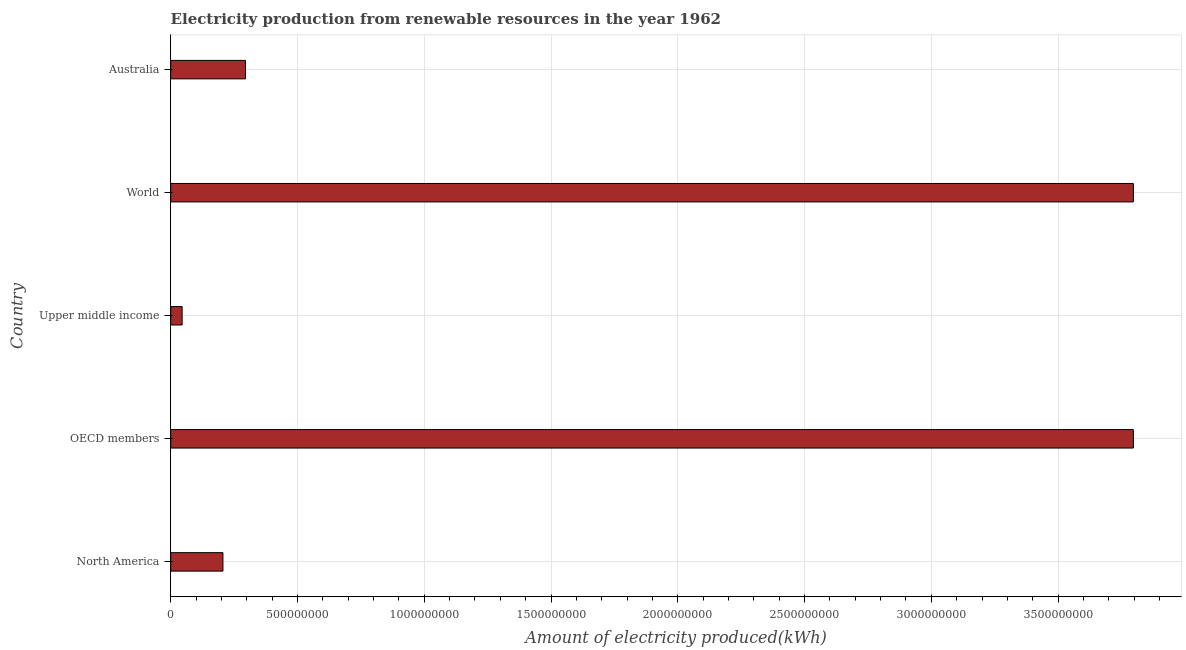Does the graph contain any zero values?
Offer a very short reply. No. Does the graph contain grids?
Provide a short and direct response. Yes. What is the title of the graph?
Ensure brevity in your answer.  Electricity production from renewable resources in the year 1962. What is the label or title of the X-axis?
Your answer should be very brief. Amount of electricity produced(kWh). What is the label or title of the Y-axis?
Offer a terse response. Country. What is the amount of electricity produced in Upper middle income?
Provide a succinct answer. 4.50e+07. Across all countries, what is the maximum amount of electricity produced?
Offer a terse response. 3.80e+09. Across all countries, what is the minimum amount of electricity produced?
Make the answer very short. 4.50e+07. In which country was the amount of electricity produced maximum?
Ensure brevity in your answer.  OECD members. In which country was the amount of electricity produced minimum?
Give a very brief answer. Upper middle income. What is the sum of the amount of electricity produced?
Ensure brevity in your answer.  8.14e+09. What is the difference between the amount of electricity produced in Australia and Upper middle income?
Offer a very short reply. 2.50e+08. What is the average amount of electricity produced per country?
Offer a terse response. 1.63e+09. What is the median amount of electricity produced?
Your response must be concise. 2.95e+08. In how many countries, is the amount of electricity produced greater than 200000000 kWh?
Make the answer very short. 4. What is the ratio of the amount of electricity produced in North America to that in OECD members?
Give a very brief answer. 0.05. What is the difference between the highest and the lowest amount of electricity produced?
Ensure brevity in your answer.  3.75e+09. In how many countries, is the amount of electricity produced greater than the average amount of electricity produced taken over all countries?
Your answer should be very brief. 2. Are all the bars in the graph horizontal?
Keep it short and to the point. Yes. How many countries are there in the graph?
Ensure brevity in your answer.  5. Are the values on the major ticks of X-axis written in scientific E-notation?
Make the answer very short. No. What is the Amount of electricity produced(kWh) of North America?
Offer a terse response. 2.06e+08. What is the Amount of electricity produced(kWh) in OECD members?
Your response must be concise. 3.80e+09. What is the Amount of electricity produced(kWh) of Upper middle income?
Provide a succinct answer. 4.50e+07. What is the Amount of electricity produced(kWh) in World?
Ensure brevity in your answer.  3.80e+09. What is the Amount of electricity produced(kWh) in Australia?
Provide a short and direct response. 2.95e+08. What is the difference between the Amount of electricity produced(kWh) in North America and OECD members?
Offer a terse response. -3.59e+09. What is the difference between the Amount of electricity produced(kWh) in North America and Upper middle income?
Keep it short and to the point. 1.61e+08. What is the difference between the Amount of electricity produced(kWh) in North America and World?
Ensure brevity in your answer.  -3.59e+09. What is the difference between the Amount of electricity produced(kWh) in North America and Australia?
Keep it short and to the point. -8.90e+07. What is the difference between the Amount of electricity produced(kWh) in OECD members and Upper middle income?
Offer a terse response. 3.75e+09. What is the difference between the Amount of electricity produced(kWh) in OECD members and World?
Keep it short and to the point. 0. What is the difference between the Amount of electricity produced(kWh) in OECD members and Australia?
Keep it short and to the point. 3.50e+09. What is the difference between the Amount of electricity produced(kWh) in Upper middle income and World?
Your response must be concise. -3.75e+09. What is the difference between the Amount of electricity produced(kWh) in Upper middle income and Australia?
Provide a succinct answer. -2.50e+08. What is the difference between the Amount of electricity produced(kWh) in World and Australia?
Make the answer very short. 3.50e+09. What is the ratio of the Amount of electricity produced(kWh) in North America to that in OECD members?
Keep it short and to the point. 0.05. What is the ratio of the Amount of electricity produced(kWh) in North America to that in Upper middle income?
Your answer should be compact. 4.58. What is the ratio of the Amount of electricity produced(kWh) in North America to that in World?
Offer a terse response. 0.05. What is the ratio of the Amount of electricity produced(kWh) in North America to that in Australia?
Provide a succinct answer. 0.7. What is the ratio of the Amount of electricity produced(kWh) in OECD members to that in Upper middle income?
Provide a succinct answer. 84.38. What is the ratio of the Amount of electricity produced(kWh) in OECD members to that in World?
Offer a terse response. 1. What is the ratio of the Amount of electricity produced(kWh) in OECD members to that in Australia?
Offer a terse response. 12.87. What is the ratio of the Amount of electricity produced(kWh) in Upper middle income to that in World?
Offer a terse response. 0.01. What is the ratio of the Amount of electricity produced(kWh) in Upper middle income to that in Australia?
Provide a short and direct response. 0.15. What is the ratio of the Amount of electricity produced(kWh) in World to that in Australia?
Make the answer very short. 12.87. 